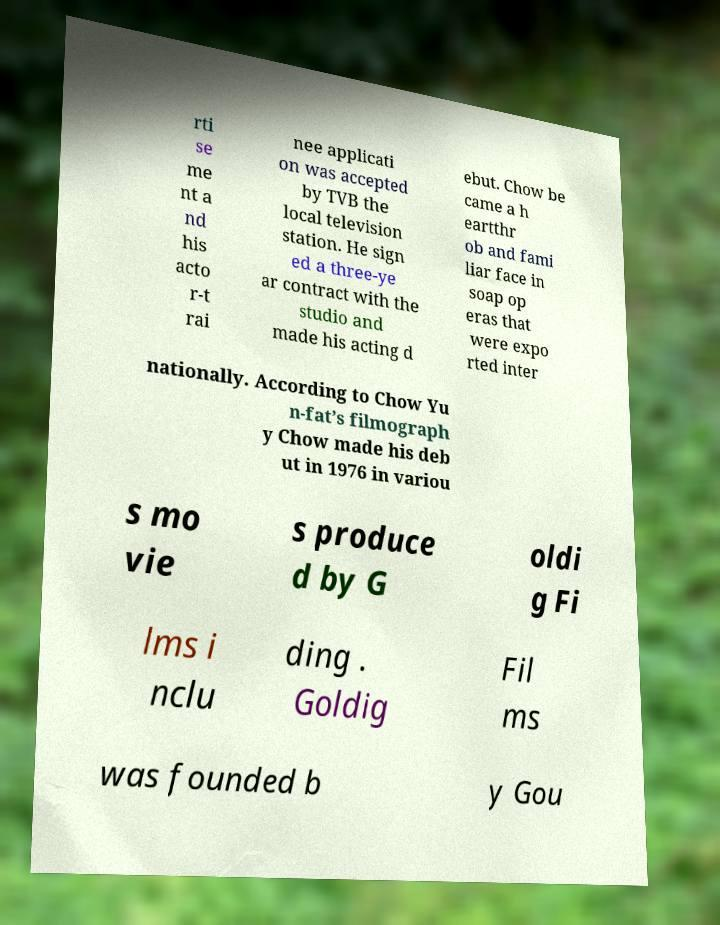Can you read and provide the text displayed in the image?This photo seems to have some interesting text. Can you extract and type it out for me? rti se me nt a nd his acto r-t rai nee applicati on was accepted by TVB the local television station. He sign ed a three-ye ar contract with the studio and made his acting d ebut. Chow be came a h eartthr ob and fami liar face in soap op eras that were expo rted inter nationally. According to Chow Yu n-fat’s filmograph y Chow made his deb ut in 1976 in variou s mo vie s produce d by G oldi g Fi lms i nclu ding . Goldig Fil ms was founded b y Gou 